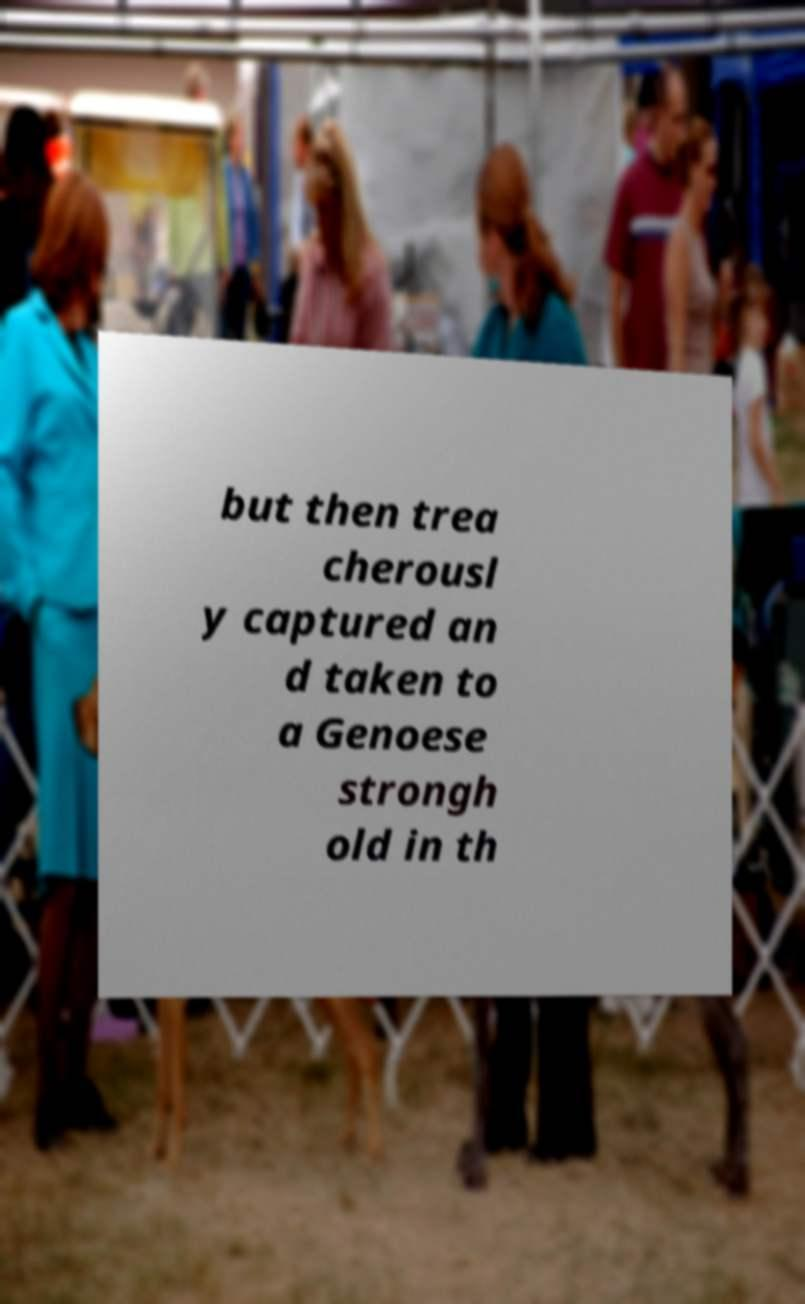Can you read and provide the text displayed in the image?This photo seems to have some interesting text. Can you extract and type it out for me? but then trea cherousl y captured an d taken to a Genoese strongh old in th 